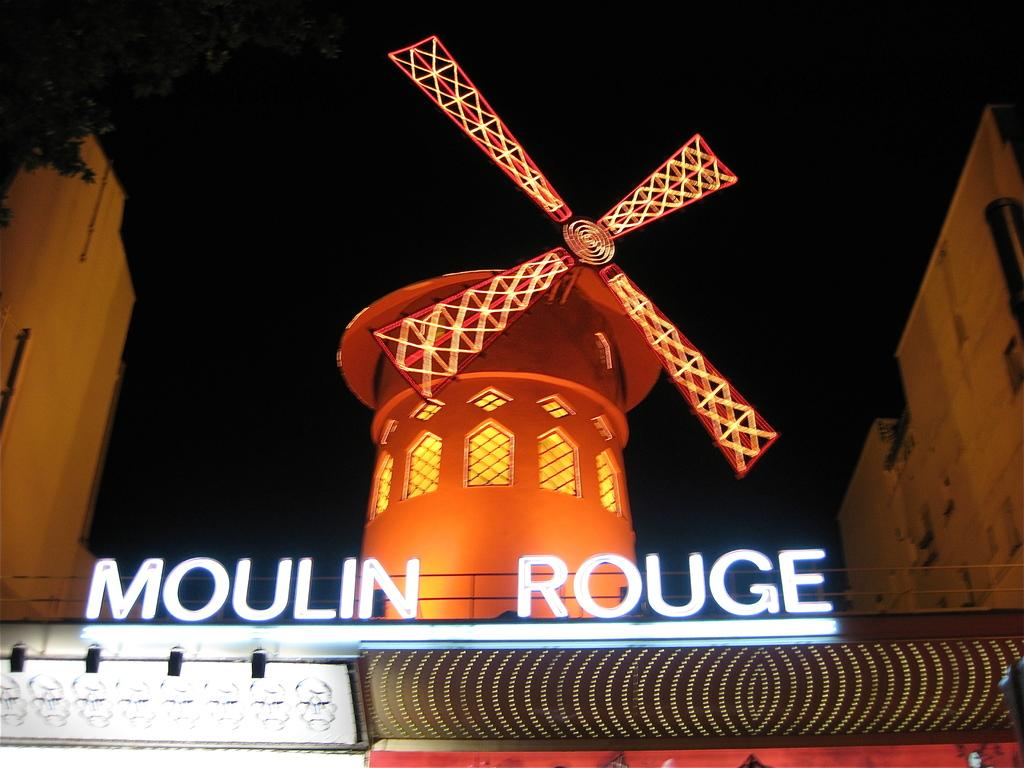What is the main subject in the center of the image? There is a windmill in the center of the image. What is located in the foreground of the image? There is a sign board in the foreground. What can be seen in the background of the image? There is a group of buildings and trees in the background. What is visible in the sky in the background of the image? The sky is visible in the background of the image. What type of plastic material can be seen in the image? There is no plastic material present in the image. What error is visible on the sign board in the image? There is no error visible on the sign board in the image. 